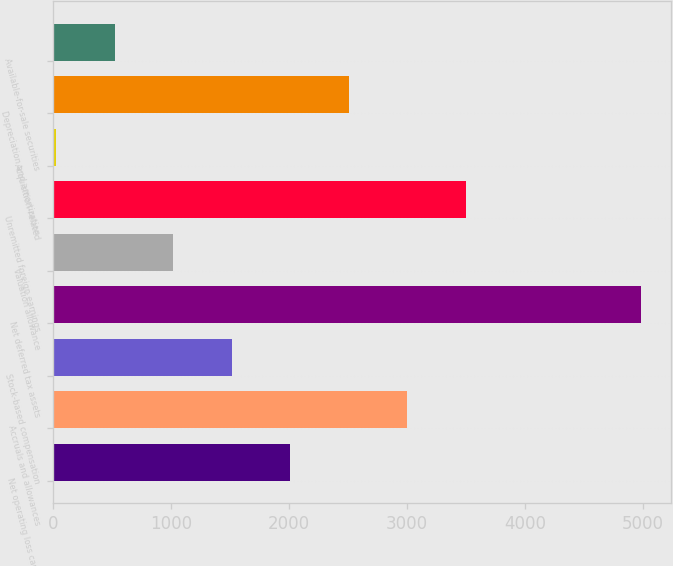<chart> <loc_0><loc_0><loc_500><loc_500><bar_chart><fcel>Net operating loss capital<fcel>Accruals and allowances<fcel>Stock-based compensation<fcel>Net deferred tax assets<fcel>Valuation allowance<fcel>Unremitted foreign earnings<fcel>Acquisition-related<fcel>Depreciation and amortization<fcel>Available-for-sale securities<nl><fcel>2011.8<fcel>3003.2<fcel>1516.1<fcel>4986<fcel>1020.4<fcel>3498.9<fcel>29<fcel>2507.5<fcel>524.7<nl></chart> 